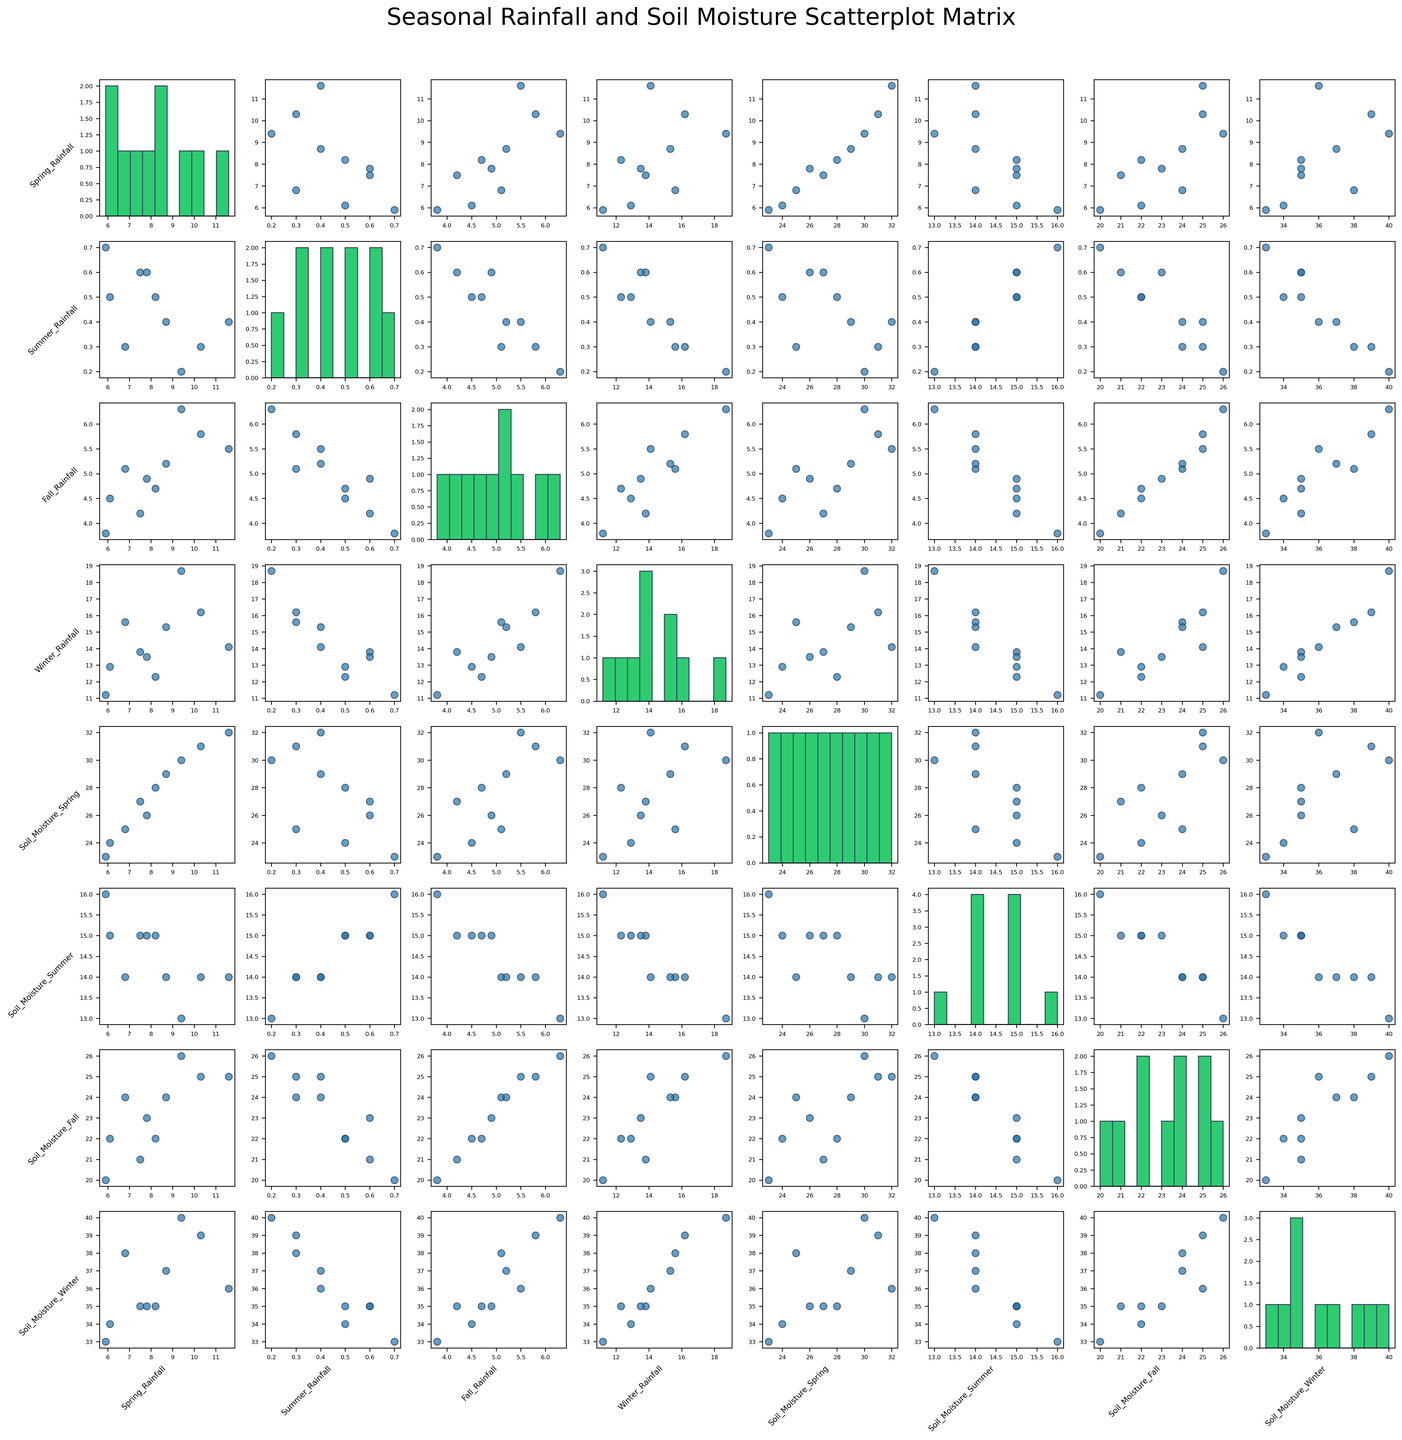What is the title of the figure? The title is located at the top center of the figure.
Answer: Seasonal Rainfall and Soil Moisture Scatterplot Matrix How is the Spring_Rainfall distributed? The diagonal plots in the scatterplot matrix for each variable are histograms. Locate the histogram on the diagonal corresponding to Spring_Rainfall to observe its distribution.
Answer: It ranges from around 5.9 to 11.6 Which variables have the strongest visual correlation with Summer Soil Moisture? Check the scatter plots in the row or column for Soil_Moisture_Summer. Look for plots where the points form a clear line or curve, indicating strong correlation.
Answer: Spring_Rainfall and Fall_Rainfall show a visual correlation Among the seasonal rainfall variables, which season seems to have the highest variability in rainfall? Look at the histograms on the diagonal for each seasonal rainfall. The histogram with the widest spread and varying bin heights indicates the highest variability.
Answer: Winter_Rainfall Which season's rainfall has the least impact on Winter Soil Moisture? Examine the scatter plots in the column for Soil_Moisture_Winter against each seasonal rainfall. The plot with the least discernible pattern or flat distribution indicates the least impact.
Answer: Summer_Rainfall Is there a visual correlation between Fall and Winter Soil Moisture? Look at the scatter plot corresponding to Soil_Moisture_Fall versus Soil_Moisture_Winter. Observe if the points follow a linear pattern.
Answer: Yes, there is a visual correlation Which variable shows a distribution peaking around the middle of its range? Check the histograms for each variable on the diagonals. If a histogram has a peak in the middle and falls off on both ends, it indicates a distribution peaking around the middle.
Answer: Soil_Moisture_Winter Does Spring Rainfall appear to affect Fall Soil Moisture? Observe the scatter plot in the matrix for Spring_Rainfall versus Soil_Moisture_Fall. A discernible pattern or trend between the points indicates an effect.
Answer: Yes, it appears to affect 